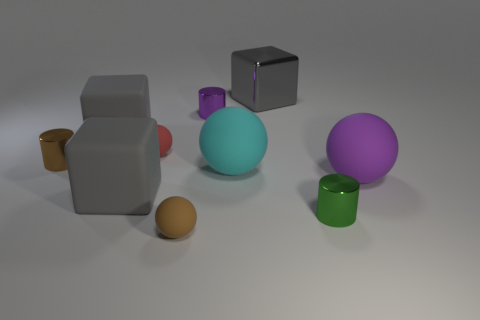Does the tiny brown shiny thing have the same shape as the tiny purple thing?
Keep it short and to the point. Yes. How many things are yellow rubber blocks or rubber objects left of the gray metal cube?
Your response must be concise. 5. Is the size of the purple object that is behind the red rubber sphere the same as the brown sphere?
Your response must be concise. Yes. There is a ball that is behind the tiny metal object that is on the left side of the tiny purple object; what number of large gray objects are in front of it?
Your response must be concise. 1. What number of brown things are big rubber balls or matte balls?
Provide a short and direct response. 1. The big ball that is the same material as the big purple thing is what color?
Give a very brief answer. Cyan. How many small things are either shiny things or red objects?
Offer a terse response. 4. Are there fewer small brown cylinders than large yellow balls?
Provide a short and direct response. No. What is the color of the other big object that is the same shape as the large purple object?
Your answer should be compact. Cyan. Are there any other things that are the same shape as the big cyan object?
Make the answer very short. Yes. 